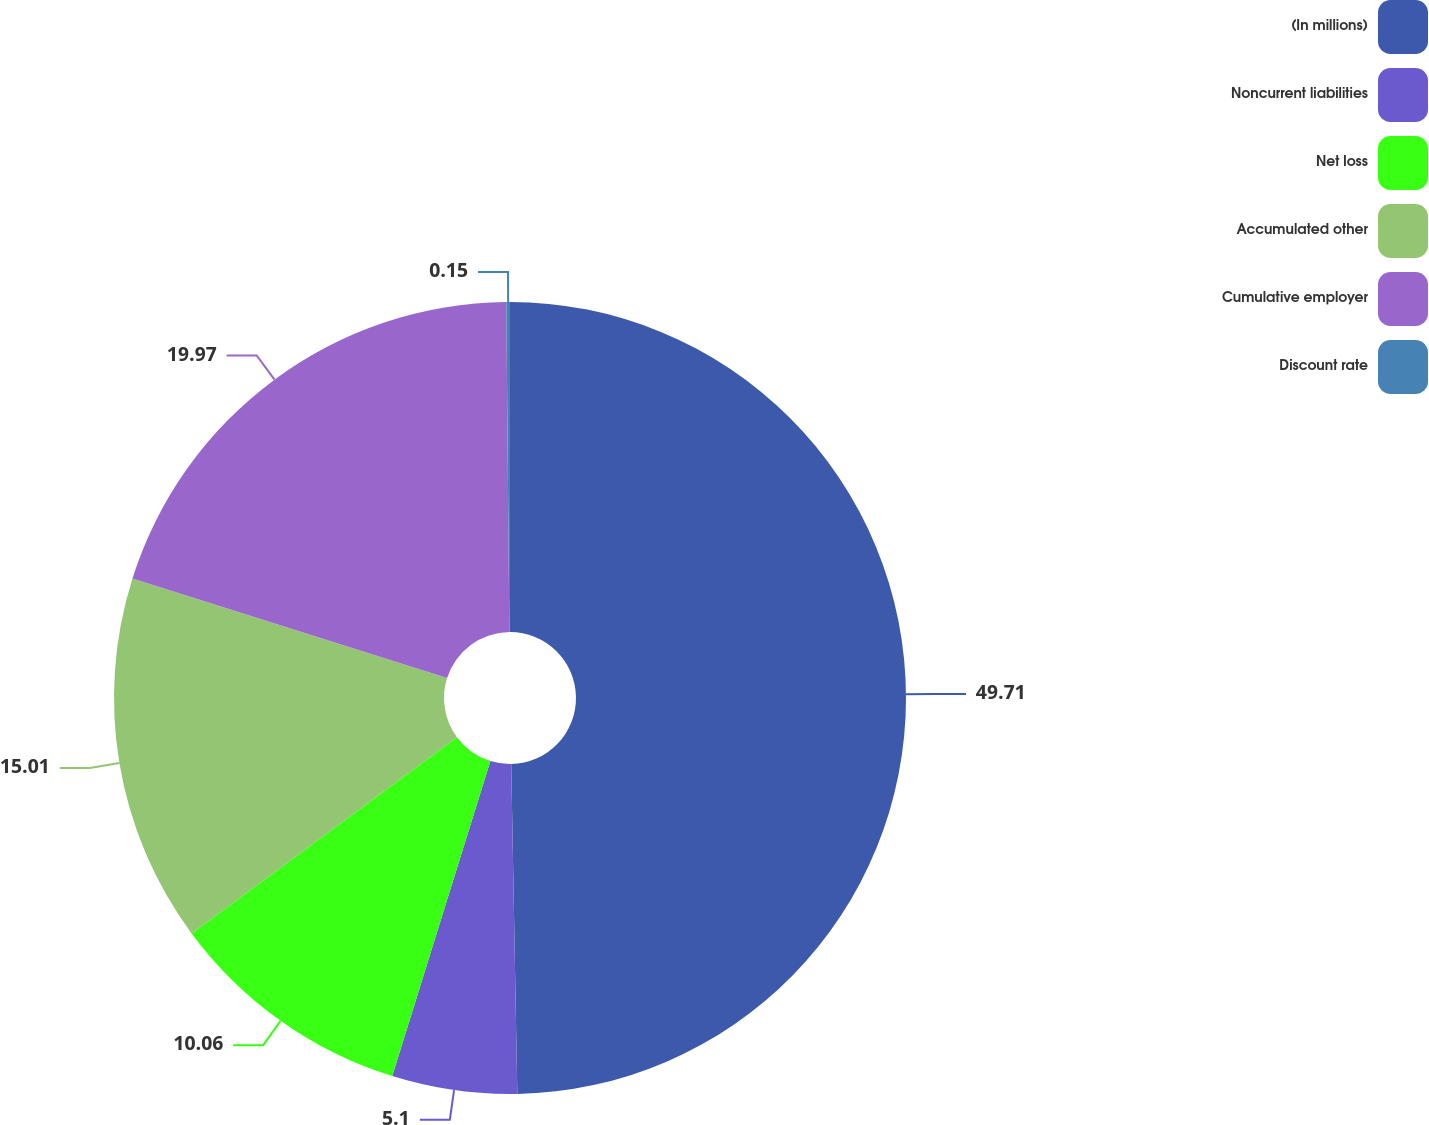<chart> <loc_0><loc_0><loc_500><loc_500><pie_chart><fcel>(In millions)<fcel>Noncurrent liabilities<fcel>Net loss<fcel>Accumulated other<fcel>Cumulative employer<fcel>Discount rate<nl><fcel>49.7%<fcel>5.1%<fcel>10.06%<fcel>15.01%<fcel>19.97%<fcel>0.15%<nl></chart> 